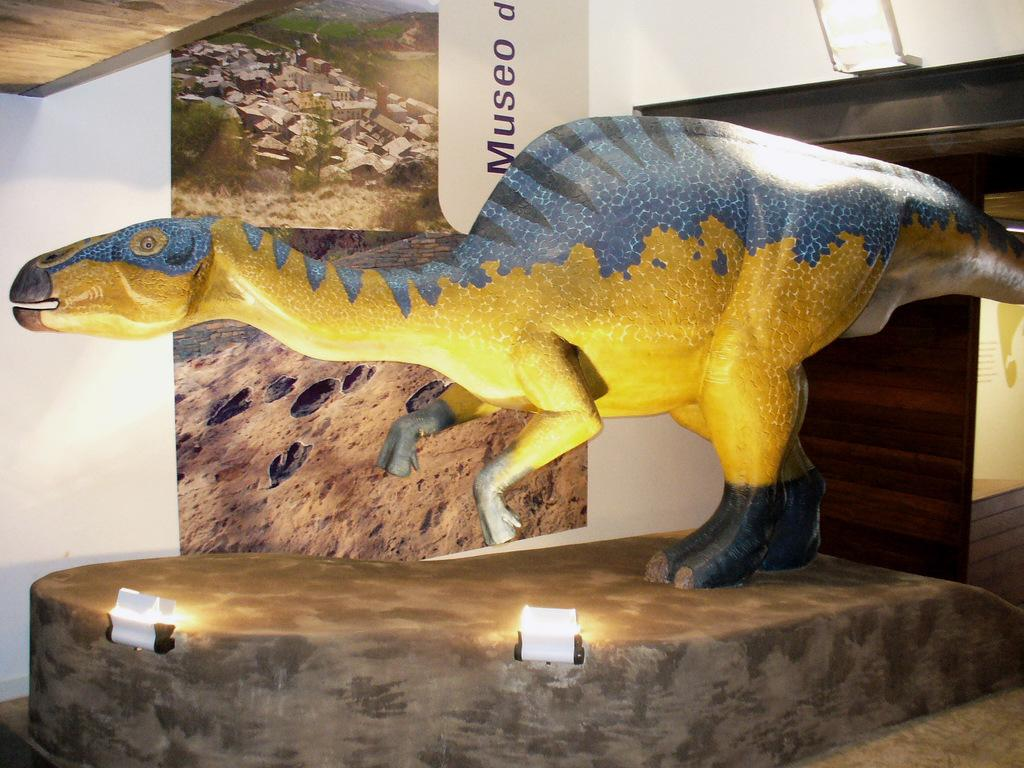What is the main subject of the image? The main subject of the image is a dinosaur idol. Are there any additional objects or features in front of the dinosaur idol? Yes, there are two lights in front of the dinosaur idol. What can be seen on the wall behind the dinosaur idol? There is a banner on the wall behind the dinosaur idol. How many chairs are placed around the dinosaur idol in the image? There are no chairs present in the image; it only features a dinosaur idol, two lights, and a banner. 